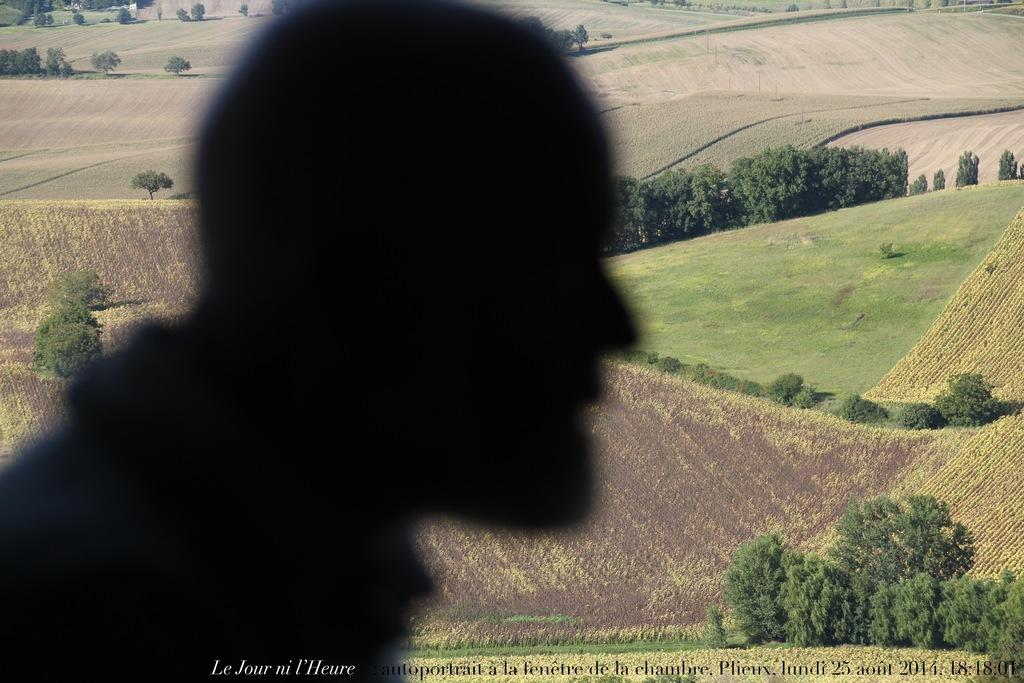What can be seen in the image that resembles a person or a shadow? There is a person or a shadow of a person in the image. What type of vegetation is present in the image? There are trees and grass in the image. Is there any text or marking at the bottom of the image? Yes, there is a watermark at the bottom of the image. What type of whip is being used by the person in the image? There is no whip present in the image; it only features a person or a shadow of a person, trees, grass, and a watermark. 